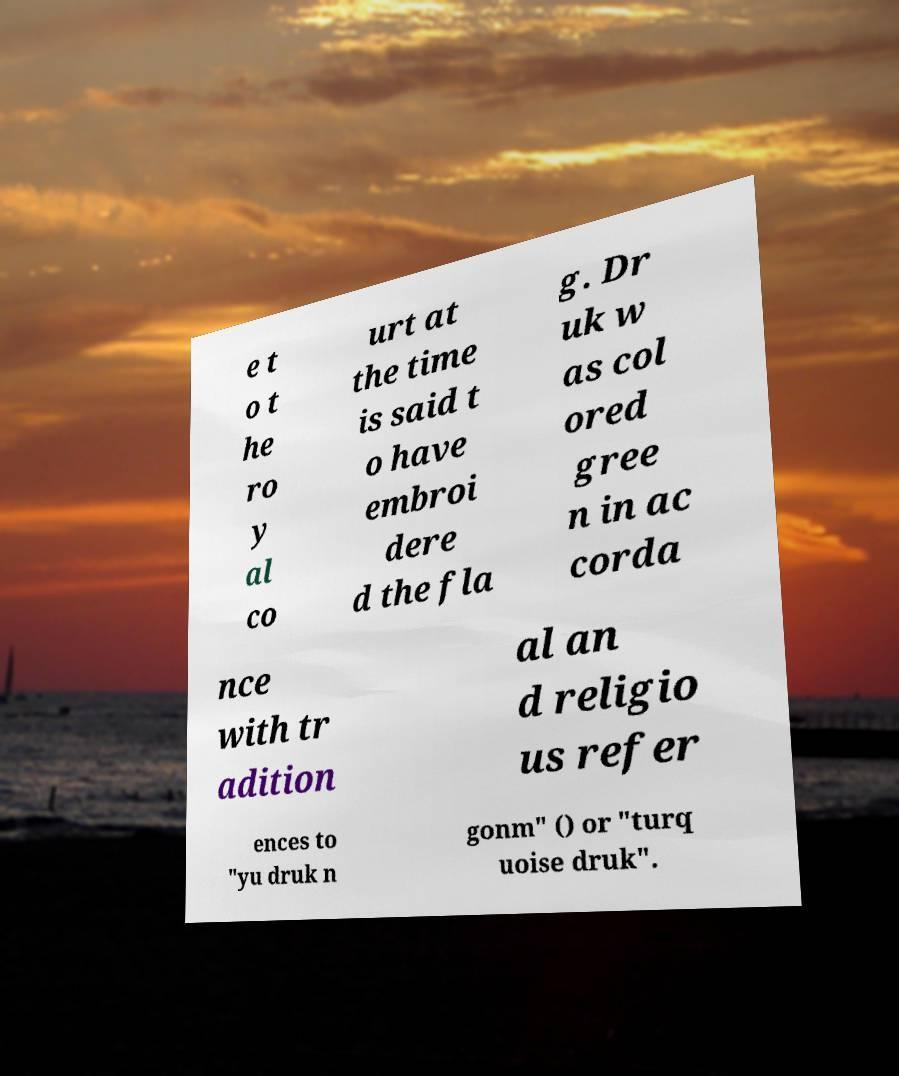Can you accurately transcribe the text from the provided image for me? e t o t he ro y al co urt at the time is said t o have embroi dere d the fla g. Dr uk w as col ored gree n in ac corda nce with tr adition al an d religio us refer ences to "yu druk n gonm" () or "turq uoise druk". 